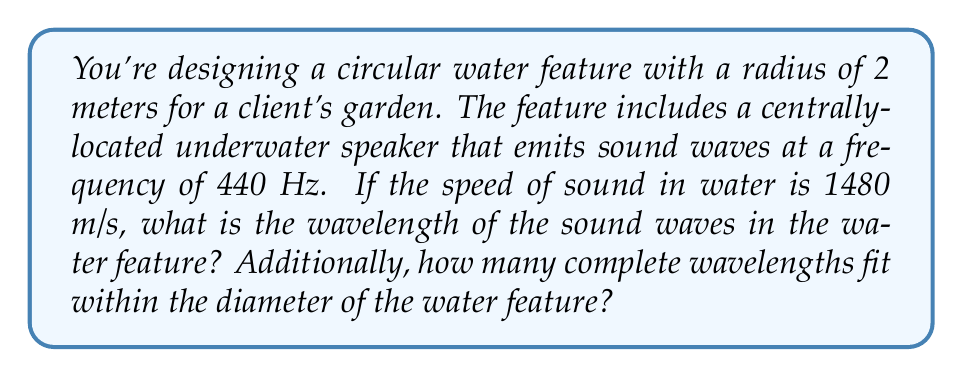Solve this math problem. Let's approach this problem step-by-step:

1) First, we need to calculate the wavelength of the sound waves in water. The wavelength ($\lambda$) is related to the speed of sound ($v$) and the frequency ($f$) by the equation:

   $$v = f\lambda$$

2) Rearranging this equation to solve for $\lambda$:

   $$\lambda = \frac{v}{f}$$

3) Substituting the given values:
   $v = 1480$ m/s (speed of sound in water)
   $f = 440$ Hz (frequency of the sound)

   $$\lambda = \frac{1480 \text{ m/s}}{440 \text{ Hz}} = 3.36363... \text{ m}$$

4) Now that we have the wavelength, we can determine how many complete wavelengths fit within the diameter of the water feature.

5) The diameter of the water feature is twice the radius:
   Diameter $= 2 \times 2 \text{ m} = 4 \text{ m}$

6) To find the number of wavelengths, we divide the diameter by the wavelength:

   $$\text{Number of wavelengths} = \frac{\text{Diameter}}{\text{Wavelength}} = \frac{4 \text{ m}}{3.36363... \text{ m}} = 1.18918...$$

7) This means that 1 complete wavelength fits within the diameter, with a small portion of a second wavelength.
Answer: Wavelength: 3.36 m; Number of complete wavelengths: 1 